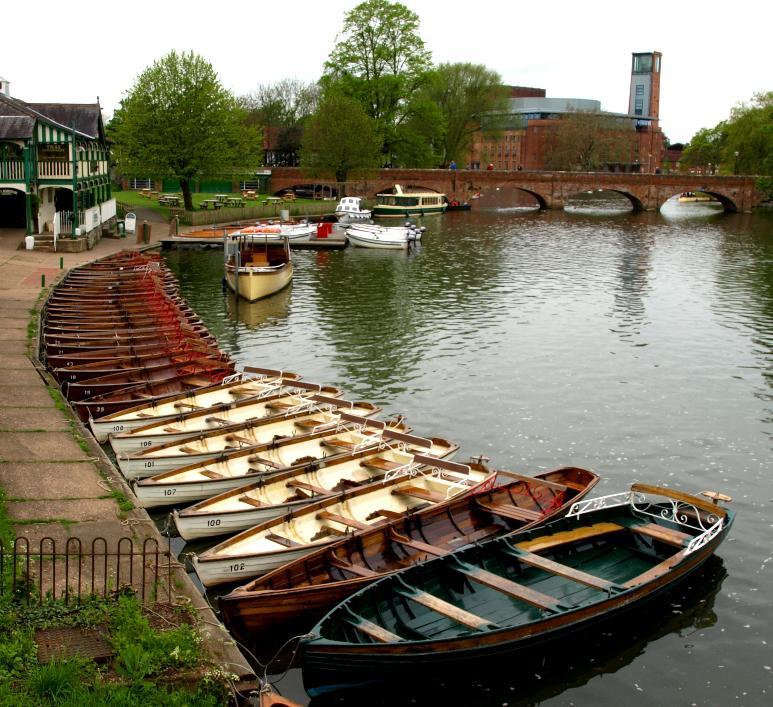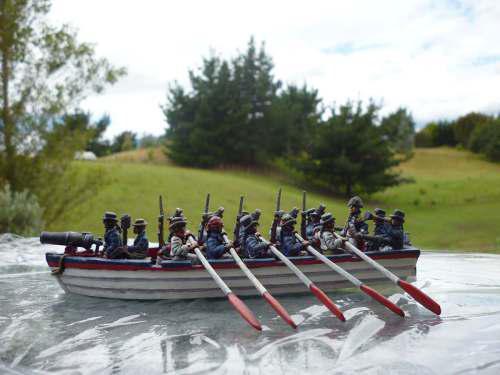The first image is the image on the left, the second image is the image on the right. Analyze the images presented: Is the assertion "At least one image shows re-enactors, people wearing period clothing, on or near a boat." valid? Answer yes or no. Yes. The first image is the image on the left, the second image is the image on the right. Assess this claim about the two images: "An image shows one white-bottomed boat on the exterior side of a ship, below a line of square ports.". Correct or not? Answer yes or no. No. 